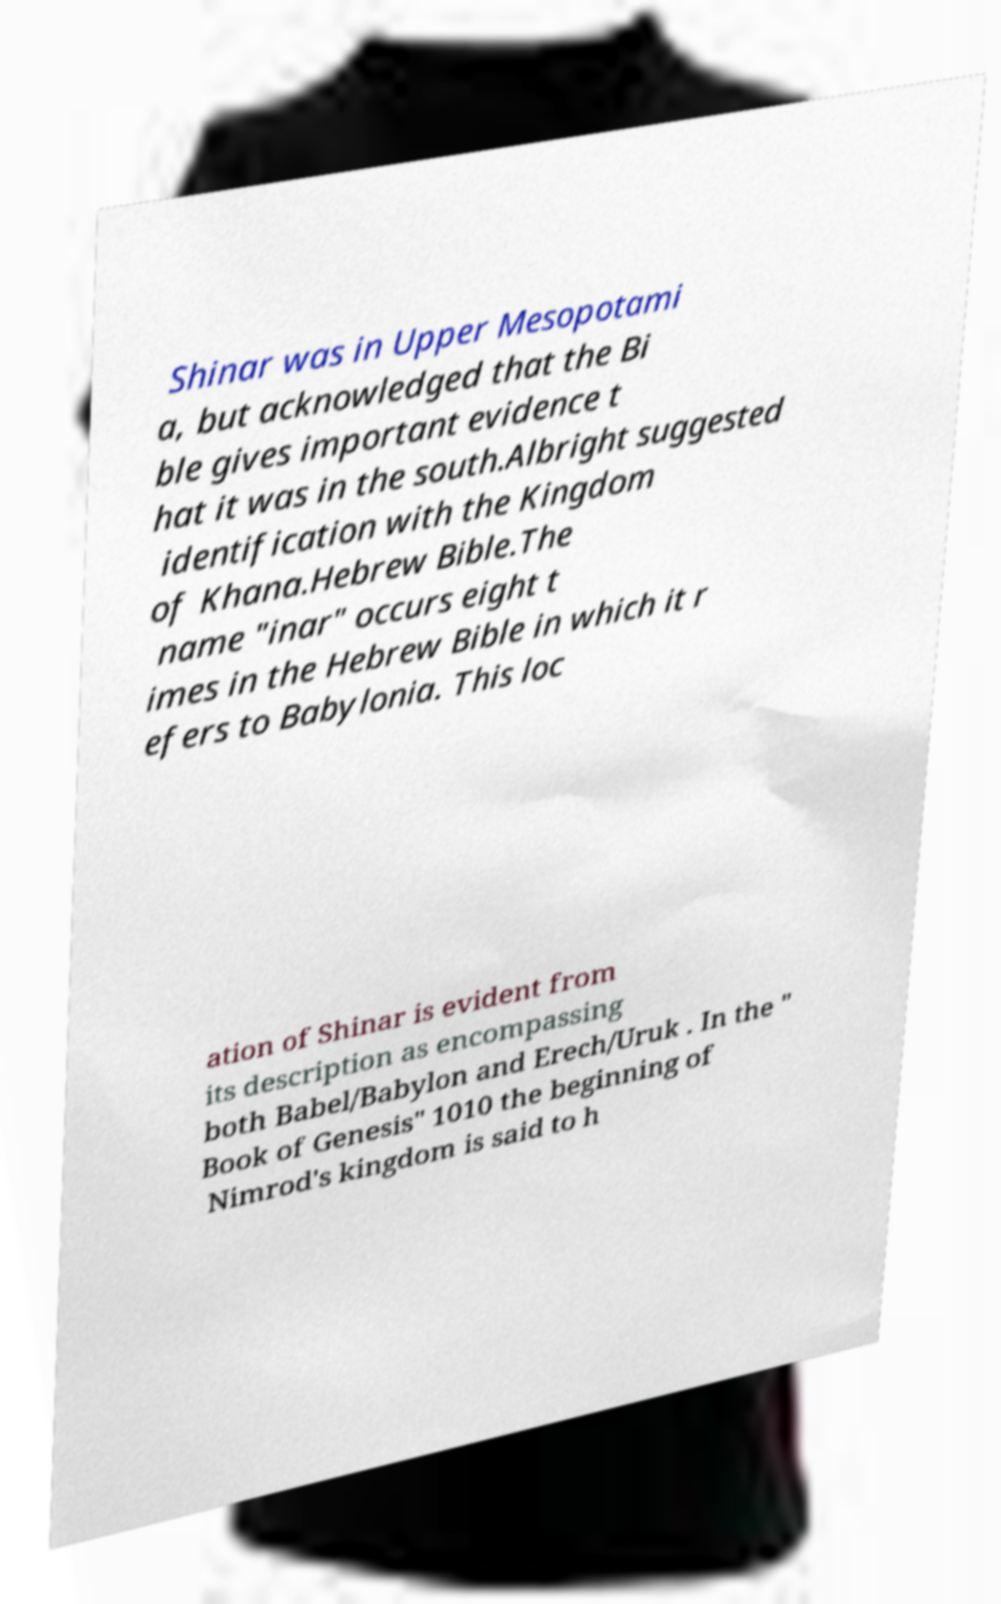For documentation purposes, I need the text within this image transcribed. Could you provide that? Shinar was in Upper Mesopotami a, but acknowledged that the Bi ble gives important evidence t hat it was in the south.Albright suggested identification with the Kingdom of Khana.Hebrew Bible.The name "inar" occurs eight t imes in the Hebrew Bible in which it r efers to Babylonia. This loc ation of Shinar is evident from its description as encompassing both Babel/Babylon and Erech/Uruk . In the " Book of Genesis" 1010 the beginning of Nimrod's kingdom is said to h 